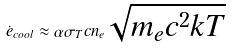Convert formula to latex. <formula><loc_0><loc_0><loc_500><loc_500>\dot { e } _ { c o o l } \approx \alpha \sigma _ { T } c n _ { e } \sqrt { m _ { e } c ^ { 2 } k T }</formula> 